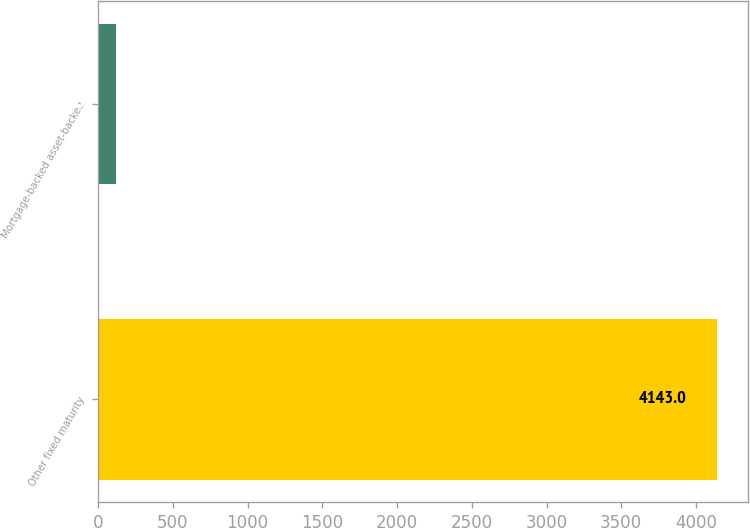Convert chart. <chart><loc_0><loc_0><loc_500><loc_500><bar_chart><fcel>Other fixed maturity<fcel>Mortgage-backed asset-backed<nl><fcel>4143<fcel>116<nl></chart> 